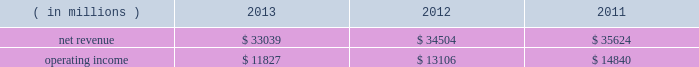Our overall gross margin percentage decreased to 59.8% ( 59.8 % ) in 2013 from 62.1% ( 62.1 % ) in 2012 .
The decrease in the gross margin percentage was primarily due to the gross margin percentage decrease in pccg .
We derived most of our overall gross margin dollars in 2013 and 2012 from the sale of platforms in the pccg and dcg operating segments .
Our net revenue for 2012 , which included 52 weeks , decreased by $ 658 million , or 1% ( 1 % ) , compared to 2011 , which included 53 weeks .
The pccg and dcg platform unit sales decreased 1% ( 1 % ) while average selling prices were unchanged .
Additionally , lower netbook platform unit sales and multi-comm average selling prices , primarily discrete modems , contributed to the decrease .
These decreases were partially offset by our mcafee operating segment , which we acquired in the q1 2011 .
Mcafee contributed $ 469 million of additional revenue in 2012 compared to 2011 .
Our overall gross margin dollars for 2012 decreased by $ 606 million , or 2% ( 2 % ) , compared to 2011 .
The decrease was due in large part to $ 494 million of excess capacity charges , as well as lower revenue from the pccg and dcg platform .
To a lesser extent , approximately $ 390 million of higher unit costs on the pccg and dcg platform as well as lower netbook and multi-comm revenue contributed to the decrease .
The decrease was partially offset by $ 643 million of lower factory start-up costs as we transition from our 22nm process technology to r&d of our next- generation 14nm process technology , as well as $ 422 million of charges recorded in 2011 to repair and replace materials and systems impacted by a design issue related to our intel ae 6 series express chipset family .
The decrease was also partially offset by the two additional months of results from our acquisition of mcafee , which occurred on february 28 , 2011 , contributing approximately $ 334 million of additional gross margin dollars in 2012 compared to 2011 .
The amortization of acquisition-related intangibles resulted in a $ 557 million reduction to our overall gross margin dollars in 2012 , compared to $ 482 million in 2011 , primarily due to acquisitions completed in q1 2011 .
Our overall gross margin percentage in 2012 was flat from 2011 as higher excess capacity charges and higher unit costs on the pccg and dcg platform were offset by lower factory start-up costs and no impact in 2012 for a design issue related to our intel 6 series express chipset family .
We derived a substantial majority of our overall gross margin dollars in 2012 and 2011 from the sale of platforms in the pccg and dcg operating segments .
Pc client group the revenue and operating income for the pccg operating segment for each period were as follows: .
Net revenue for the pccg operating segment decreased by $ 1.5 billion , or 4% ( 4 % ) , in 2013 compared to 2012 .
Pccg platform unit sales were down 3% ( 3 % ) primarily on softness in traditional pc demand during the first nine months of the year .
The decrease in revenue was driven by lower notebook and desktop platform unit sales which were down 4% ( 4 % ) and 2% ( 2 % ) , respectively .
Pccg platform average selling prices were flat , with 6% ( 6 % ) higher desktop platform average selling prices offset by 4% ( 4 % ) lower notebook platform average selling prices .
Operating income decreased by $ 1.3 billion , or 10% ( 10 % ) , in 2013 compared to 2012 , which was driven by $ 1.5 billion of lower gross margin , partially offset by $ 200 million of lower operating expenses .
The decrease in gross margin was driven by $ 1.5 billion of higher factory start-up costs primarily on our next-generation 14nm process technology as well as lower pccg platform revenue .
These decreases were partially offset by approximately $ 520 million of lower pccg platform unit costs , $ 260 million of lower excess capacity charges , and higher sell-through of previously non- qualified units .
Net revenue for the pccg operating segment decreased by $ 1.1 billion , or 3% ( 3 % ) , in 2012 compared to 2011 .
Pccg revenue was negatively impacted by the growth of tablets as these devices compete with pcs for consumer sales .
Platform average selling prices and unit sales decreased 2% ( 2 % ) and 1% ( 1 % ) , respectively .
The decrease was driven by 6% ( 6 % ) lower notebook platform average selling prices and 5% ( 5 % ) lower desktop platform unit sales .
These decreases were partially offset by a 4% ( 4 % ) increase in desktop platform average selling prices and a 2% ( 2 % ) increase in notebook platform unit sales .
Table of contents management 2019s discussion and analysis of financial condition and results of operations ( continued ) .
What was the operating margin for the pc client group in 2013? 
Computations: (11827 / 33039)
Answer: 0.35797. 